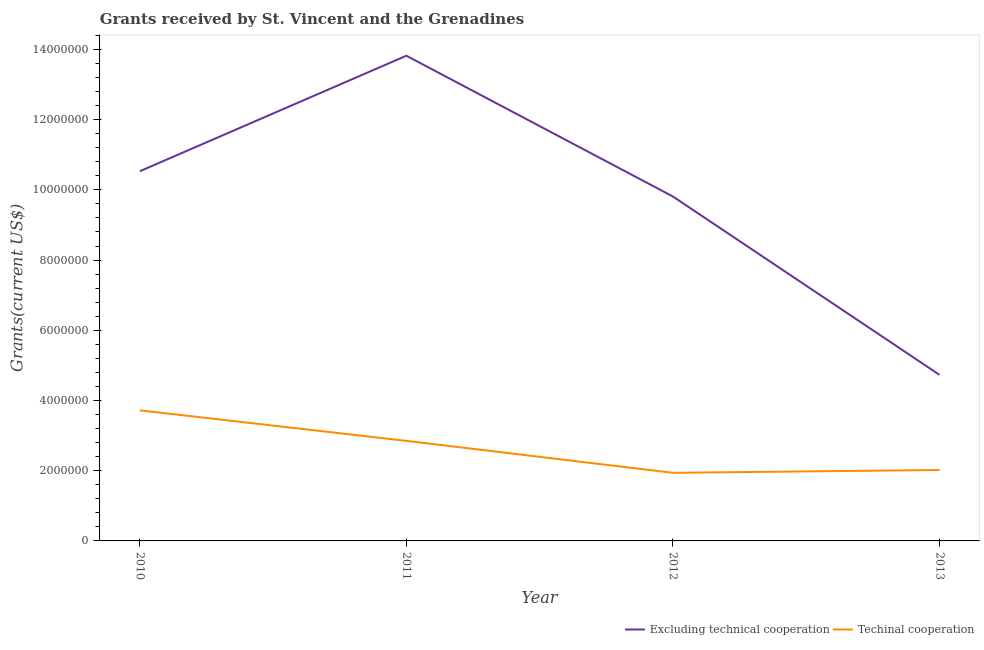How many different coloured lines are there?
Your response must be concise. 2. Is the number of lines equal to the number of legend labels?
Offer a very short reply. Yes. What is the amount of grants received(including technical cooperation) in 2011?
Give a very brief answer. 2.85e+06. Across all years, what is the maximum amount of grants received(including technical cooperation)?
Ensure brevity in your answer.  3.72e+06. Across all years, what is the minimum amount of grants received(excluding technical cooperation)?
Give a very brief answer. 4.73e+06. In which year was the amount of grants received(including technical cooperation) minimum?
Provide a succinct answer. 2012. What is the total amount of grants received(excluding technical cooperation) in the graph?
Your answer should be very brief. 3.89e+07. What is the difference between the amount of grants received(excluding technical cooperation) in 2010 and that in 2012?
Provide a succinct answer. 7.20e+05. What is the difference between the amount of grants received(excluding technical cooperation) in 2012 and the amount of grants received(including technical cooperation) in 2010?
Provide a short and direct response. 6.09e+06. What is the average amount of grants received(including technical cooperation) per year?
Provide a short and direct response. 2.63e+06. In the year 2011, what is the difference between the amount of grants received(excluding technical cooperation) and amount of grants received(including technical cooperation)?
Provide a succinct answer. 1.10e+07. What is the ratio of the amount of grants received(including technical cooperation) in 2011 to that in 2012?
Keep it short and to the point. 1.47. Is the amount of grants received(including technical cooperation) in 2011 less than that in 2013?
Your response must be concise. No. What is the difference between the highest and the second highest amount of grants received(including technical cooperation)?
Make the answer very short. 8.70e+05. What is the difference between the highest and the lowest amount of grants received(including technical cooperation)?
Ensure brevity in your answer.  1.78e+06. In how many years, is the amount of grants received(including technical cooperation) greater than the average amount of grants received(including technical cooperation) taken over all years?
Provide a succinct answer. 2. Does the amount of grants received(including technical cooperation) monotonically increase over the years?
Offer a terse response. No. How many years are there in the graph?
Provide a succinct answer. 4. Does the graph contain any zero values?
Offer a very short reply. No. How many legend labels are there?
Give a very brief answer. 2. How are the legend labels stacked?
Provide a succinct answer. Horizontal. What is the title of the graph?
Make the answer very short. Grants received by St. Vincent and the Grenadines. Does "Girls" appear as one of the legend labels in the graph?
Keep it short and to the point. No. What is the label or title of the X-axis?
Offer a very short reply. Year. What is the label or title of the Y-axis?
Keep it short and to the point. Grants(current US$). What is the Grants(current US$) in Excluding technical cooperation in 2010?
Keep it short and to the point. 1.05e+07. What is the Grants(current US$) of Techinal cooperation in 2010?
Your answer should be very brief. 3.72e+06. What is the Grants(current US$) in Excluding technical cooperation in 2011?
Provide a succinct answer. 1.38e+07. What is the Grants(current US$) of Techinal cooperation in 2011?
Make the answer very short. 2.85e+06. What is the Grants(current US$) of Excluding technical cooperation in 2012?
Offer a terse response. 9.81e+06. What is the Grants(current US$) in Techinal cooperation in 2012?
Give a very brief answer. 1.94e+06. What is the Grants(current US$) in Excluding technical cooperation in 2013?
Offer a very short reply. 4.73e+06. What is the Grants(current US$) of Techinal cooperation in 2013?
Give a very brief answer. 2.02e+06. Across all years, what is the maximum Grants(current US$) of Excluding technical cooperation?
Offer a very short reply. 1.38e+07. Across all years, what is the maximum Grants(current US$) of Techinal cooperation?
Offer a very short reply. 3.72e+06. Across all years, what is the minimum Grants(current US$) in Excluding technical cooperation?
Make the answer very short. 4.73e+06. Across all years, what is the minimum Grants(current US$) in Techinal cooperation?
Give a very brief answer. 1.94e+06. What is the total Grants(current US$) of Excluding technical cooperation in the graph?
Offer a very short reply. 3.89e+07. What is the total Grants(current US$) of Techinal cooperation in the graph?
Your answer should be very brief. 1.05e+07. What is the difference between the Grants(current US$) in Excluding technical cooperation in 2010 and that in 2011?
Your answer should be very brief. -3.29e+06. What is the difference between the Grants(current US$) of Techinal cooperation in 2010 and that in 2011?
Provide a succinct answer. 8.70e+05. What is the difference between the Grants(current US$) in Excluding technical cooperation in 2010 and that in 2012?
Make the answer very short. 7.20e+05. What is the difference between the Grants(current US$) of Techinal cooperation in 2010 and that in 2012?
Ensure brevity in your answer.  1.78e+06. What is the difference between the Grants(current US$) in Excluding technical cooperation in 2010 and that in 2013?
Your response must be concise. 5.80e+06. What is the difference between the Grants(current US$) of Techinal cooperation in 2010 and that in 2013?
Give a very brief answer. 1.70e+06. What is the difference between the Grants(current US$) of Excluding technical cooperation in 2011 and that in 2012?
Ensure brevity in your answer.  4.01e+06. What is the difference between the Grants(current US$) in Techinal cooperation in 2011 and that in 2012?
Give a very brief answer. 9.10e+05. What is the difference between the Grants(current US$) of Excluding technical cooperation in 2011 and that in 2013?
Keep it short and to the point. 9.09e+06. What is the difference between the Grants(current US$) in Techinal cooperation in 2011 and that in 2013?
Your response must be concise. 8.30e+05. What is the difference between the Grants(current US$) of Excluding technical cooperation in 2012 and that in 2013?
Your response must be concise. 5.08e+06. What is the difference between the Grants(current US$) of Excluding technical cooperation in 2010 and the Grants(current US$) of Techinal cooperation in 2011?
Your answer should be compact. 7.68e+06. What is the difference between the Grants(current US$) of Excluding technical cooperation in 2010 and the Grants(current US$) of Techinal cooperation in 2012?
Ensure brevity in your answer.  8.59e+06. What is the difference between the Grants(current US$) of Excluding technical cooperation in 2010 and the Grants(current US$) of Techinal cooperation in 2013?
Your answer should be very brief. 8.51e+06. What is the difference between the Grants(current US$) of Excluding technical cooperation in 2011 and the Grants(current US$) of Techinal cooperation in 2012?
Provide a short and direct response. 1.19e+07. What is the difference between the Grants(current US$) in Excluding technical cooperation in 2011 and the Grants(current US$) in Techinal cooperation in 2013?
Keep it short and to the point. 1.18e+07. What is the difference between the Grants(current US$) in Excluding technical cooperation in 2012 and the Grants(current US$) in Techinal cooperation in 2013?
Make the answer very short. 7.79e+06. What is the average Grants(current US$) of Excluding technical cooperation per year?
Give a very brief answer. 9.72e+06. What is the average Grants(current US$) in Techinal cooperation per year?
Offer a terse response. 2.63e+06. In the year 2010, what is the difference between the Grants(current US$) in Excluding technical cooperation and Grants(current US$) in Techinal cooperation?
Offer a terse response. 6.81e+06. In the year 2011, what is the difference between the Grants(current US$) in Excluding technical cooperation and Grants(current US$) in Techinal cooperation?
Keep it short and to the point. 1.10e+07. In the year 2012, what is the difference between the Grants(current US$) of Excluding technical cooperation and Grants(current US$) of Techinal cooperation?
Your response must be concise. 7.87e+06. In the year 2013, what is the difference between the Grants(current US$) of Excluding technical cooperation and Grants(current US$) of Techinal cooperation?
Your answer should be very brief. 2.71e+06. What is the ratio of the Grants(current US$) in Excluding technical cooperation in 2010 to that in 2011?
Ensure brevity in your answer.  0.76. What is the ratio of the Grants(current US$) of Techinal cooperation in 2010 to that in 2011?
Offer a very short reply. 1.31. What is the ratio of the Grants(current US$) of Excluding technical cooperation in 2010 to that in 2012?
Provide a short and direct response. 1.07. What is the ratio of the Grants(current US$) in Techinal cooperation in 2010 to that in 2012?
Provide a succinct answer. 1.92. What is the ratio of the Grants(current US$) in Excluding technical cooperation in 2010 to that in 2013?
Your answer should be compact. 2.23. What is the ratio of the Grants(current US$) in Techinal cooperation in 2010 to that in 2013?
Provide a short and direct response. 1.84. What is the ratio of the Grants(current US$) in Excluding technical cooperation in 2011 to that in 2012?
Provide a short and direct response. 1.41. What is the ratio of the Grants(current US$) in Techinal cooperation in 2011 to that in 2012?
Ensure brevity in your answer.  1.47. What is the ratio of the Grants(current US$) in Excluding technical cooperation in 2011 to that in 2013?
Your answer should be very brief. 2.92. What is the ratio of the Grants(current US$) of Techinal cooperation in 2011 to that in 2013?
Provide a succinct answer. 1.41. What is the ratio of the Grants(current US$) in Excluding technical cooperation in 2012 to that in 2013?
Offer a very short reply. 2.07. What is the ratio of the Grants(current US$) in Techinal cooperation in 2012 to that in 2013?
Give a very brief answer. 0.96. What is the difference between the highest and the second highest Grants(current US$) in Excluding technical cooperation?
Provide a succinct answer. 3.29e+06. What is the difference between the highest and the second highest Grants(current US$) of Techinal cooperation?
Your response must be concise. 8.70e+05. What is the difference between the highest and the lowest Grants(current US$) in Excluding technical cooperation?
Keep it short and to the point. 9.09e+06. What is the difference between the highest and the lowest Grants(current US$) of Techinal cooperation?
Provide a succinct answer. 1.78e+06. 